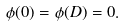Convert formula to latex. <formula><loc_0><loc_0><loc_500><loc_500>\phi ( 0 ) = \phi ( D ) = 0 .</formula> 